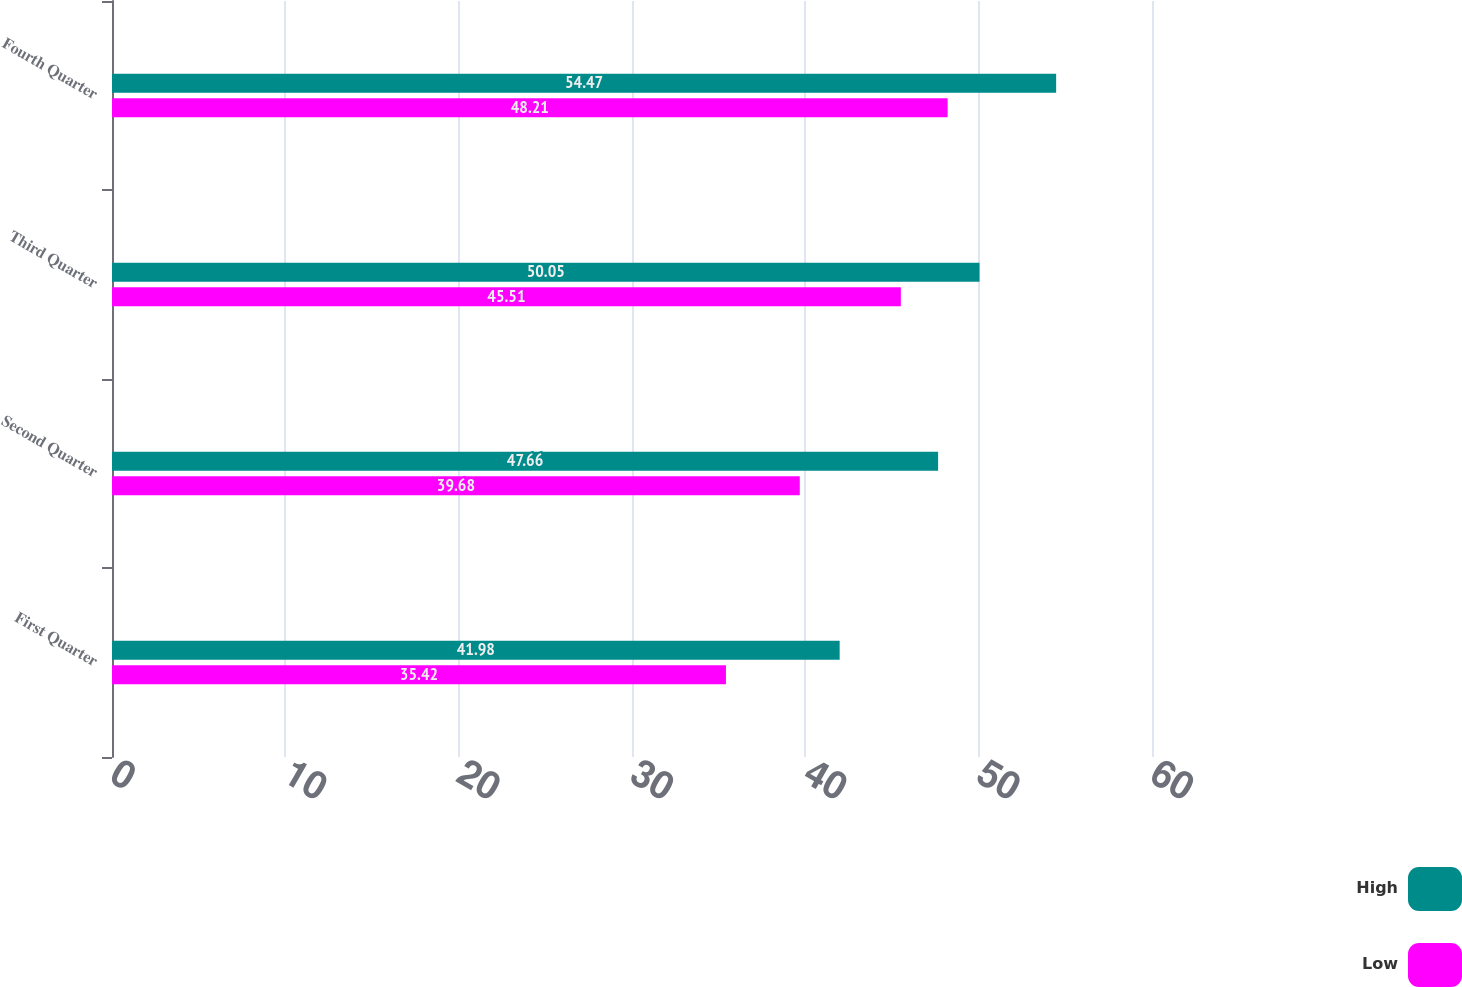Convert chart. <chart><loc_0><loc_0><loc_500><loc_500><stacked_bar_chart><ecel><fcel>First Quarter<fcel>Second Quarter<fcel>Third Quarter<fcel>Fourth Quarter<nl><fcel>High<fcel>41.98<fcel>47.66<fcel>50.05<fcel>54.47<nl><fcel>Low<fcel>35.42<fcel>39.68<fcel>45.51<fcel>48.21<nl></chart> 